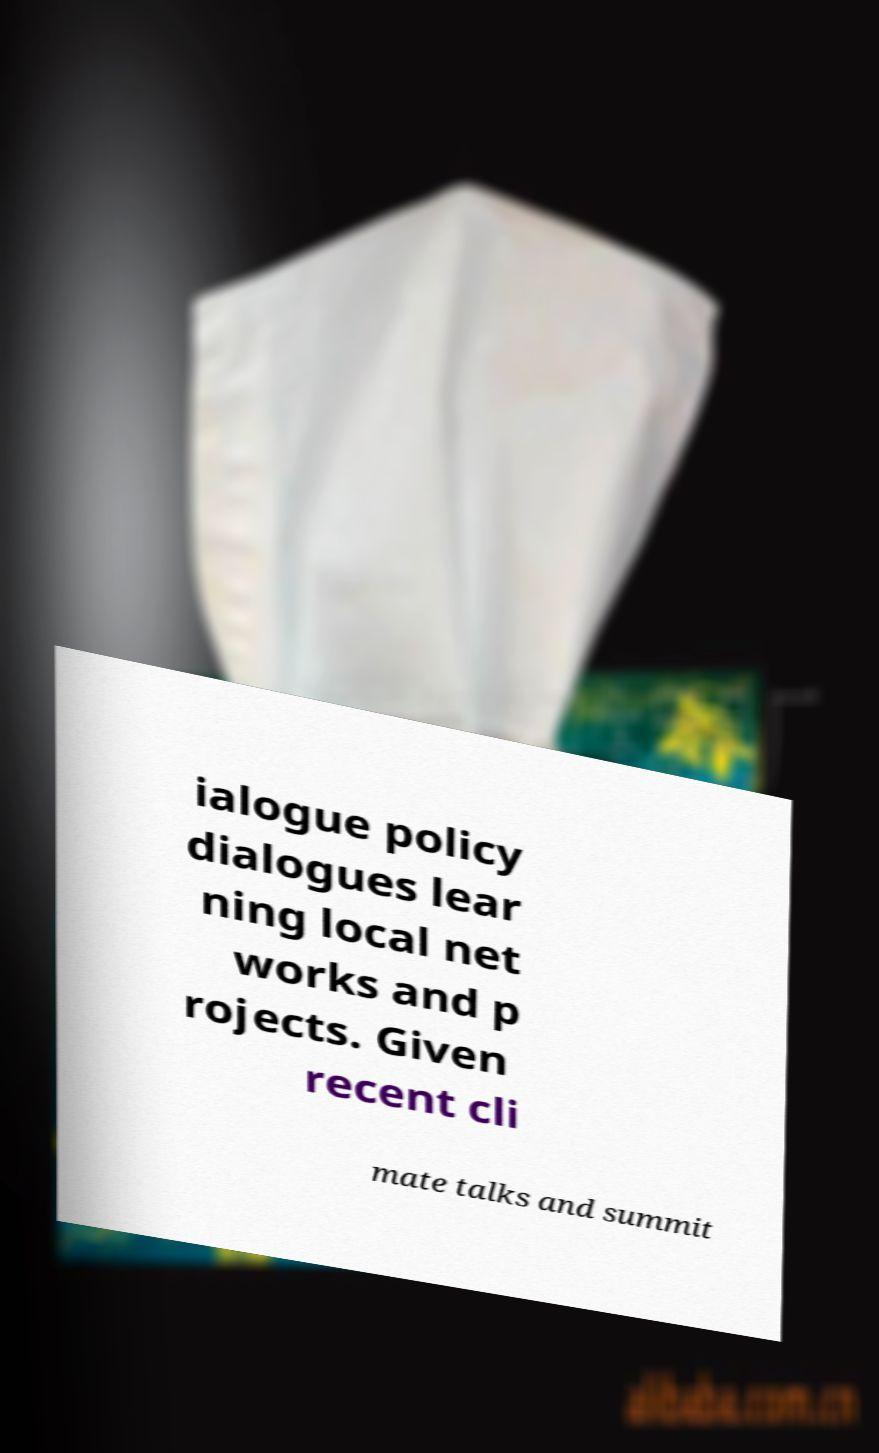What messages or text are displayed in this image? I need them in a readable, typed format. ialogue policy dialogues lear ning local net works and p rojects. Given recent cli mate talks and summit 